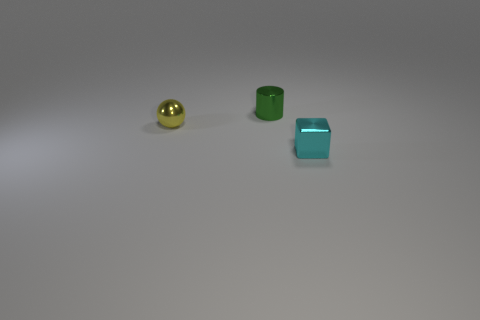Add 3 gray matte blocks. How many objects exist? 6 Subtract all blocks. How many objects are left? 2 Subtract 0 purple blocks. How many objects are left? 3 Subtract all green cubes. Subtract all tiny green cylinders. How many objects are left? 2 Add 3 cyan shiny objects. How many cyan shiny objects are left? 4 Add 3 tiny cyan shiny cylinders. How many tiny cyan shiny cylinders exist? 3 